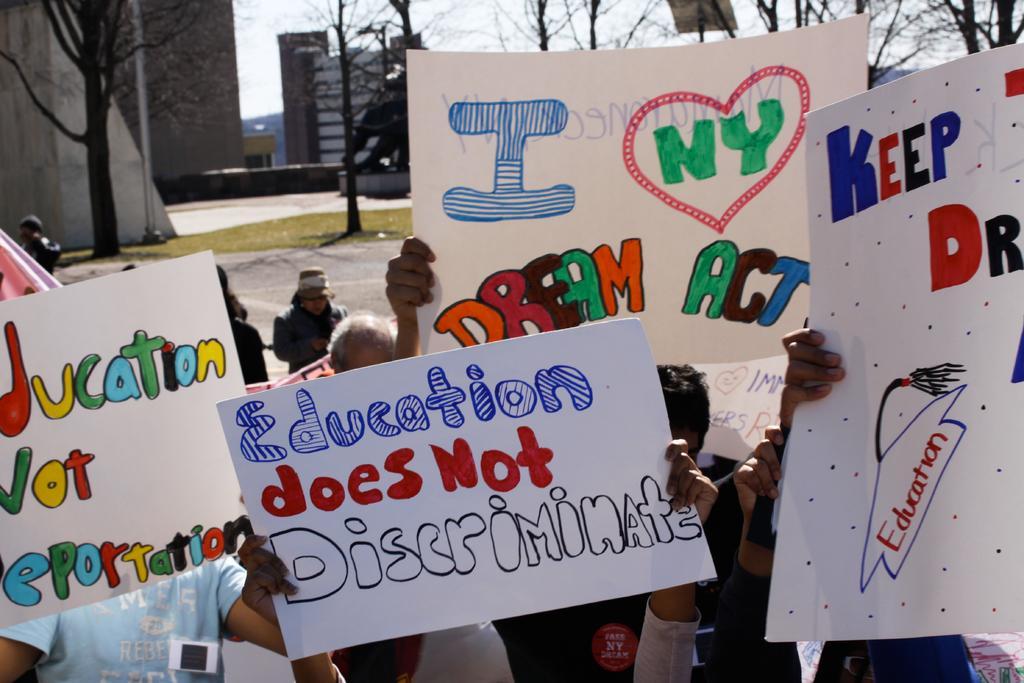Describe this image in one or two sentences. In this image we can see a group of people standing. In that some are holding the boards with some text on it. On the backside we can see a group of trees, some buildings, grass and the sky which looks cloudy. 